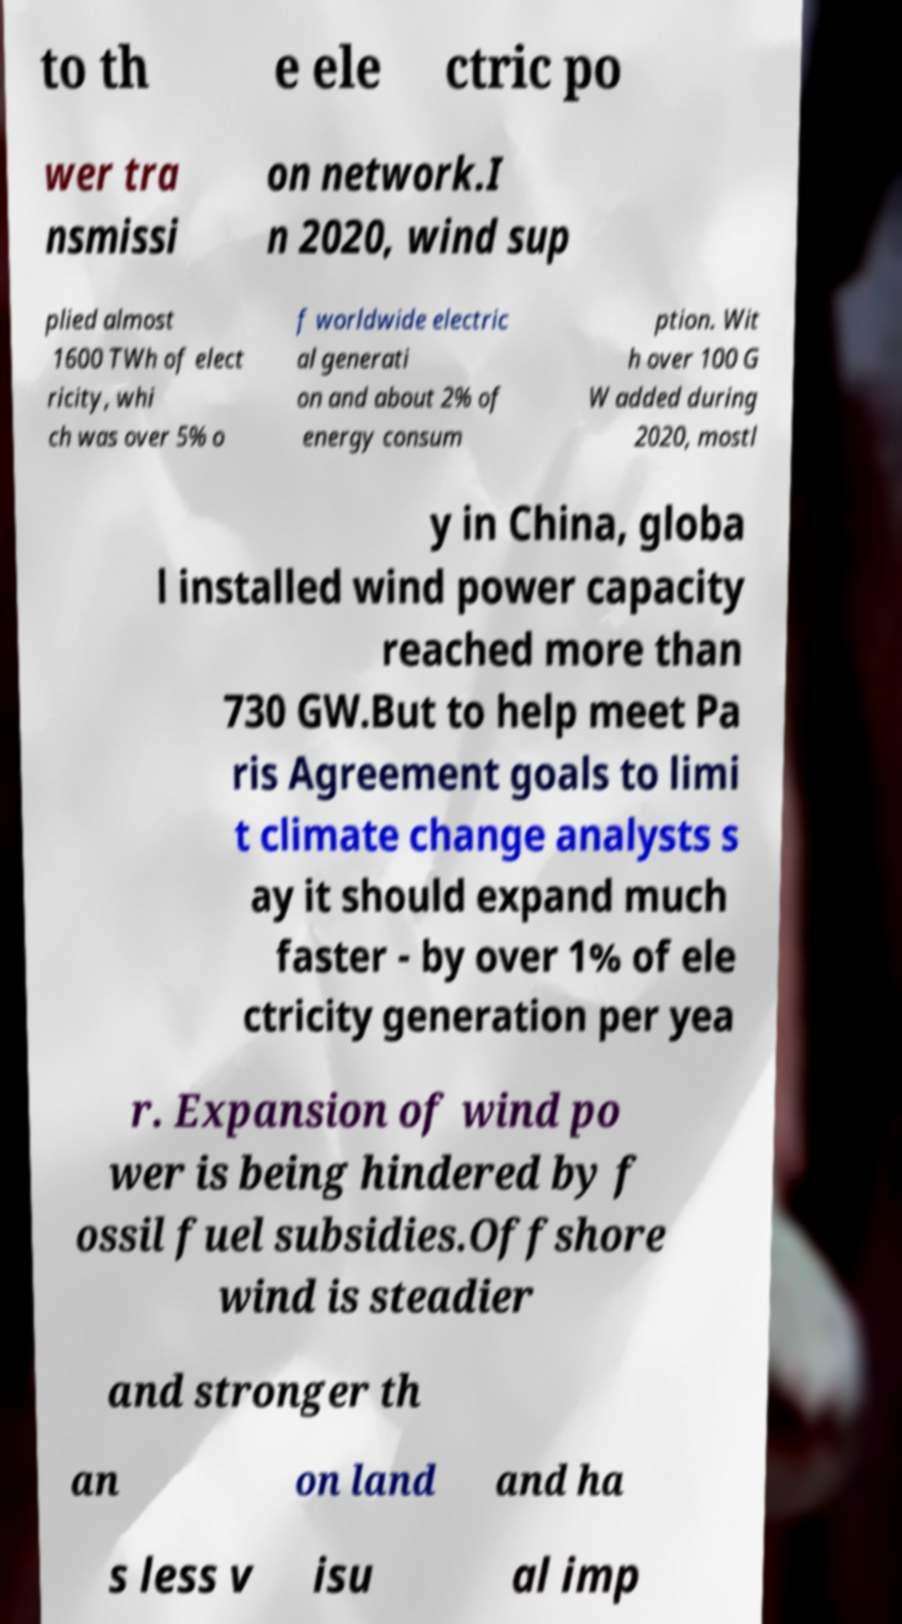I need the written content from this picture converted into text. Can you do that? to th e ele ctric po wer tra nsmissi on network.I n 2020, wind sup plied almost 1600 TWh of elect ricity, whi ch was over 5% o f worldwide electric al generati on and about 2% of energy consum ption. Wit h over 100 G W added during 2020, mostl y in China, globa l installed wind power capacity reached more than 730 GW.But to help meet Pa ris Agreement goals to limi t climate change analysts s ay it should expand much faster - by over 1% of ele ctricity generation per yea r. Expansion of wind po wer is being hindered by f ossil fuel subsidies.Offshore wind is steadier and stronger th an on land and ha s less v isu al imp 